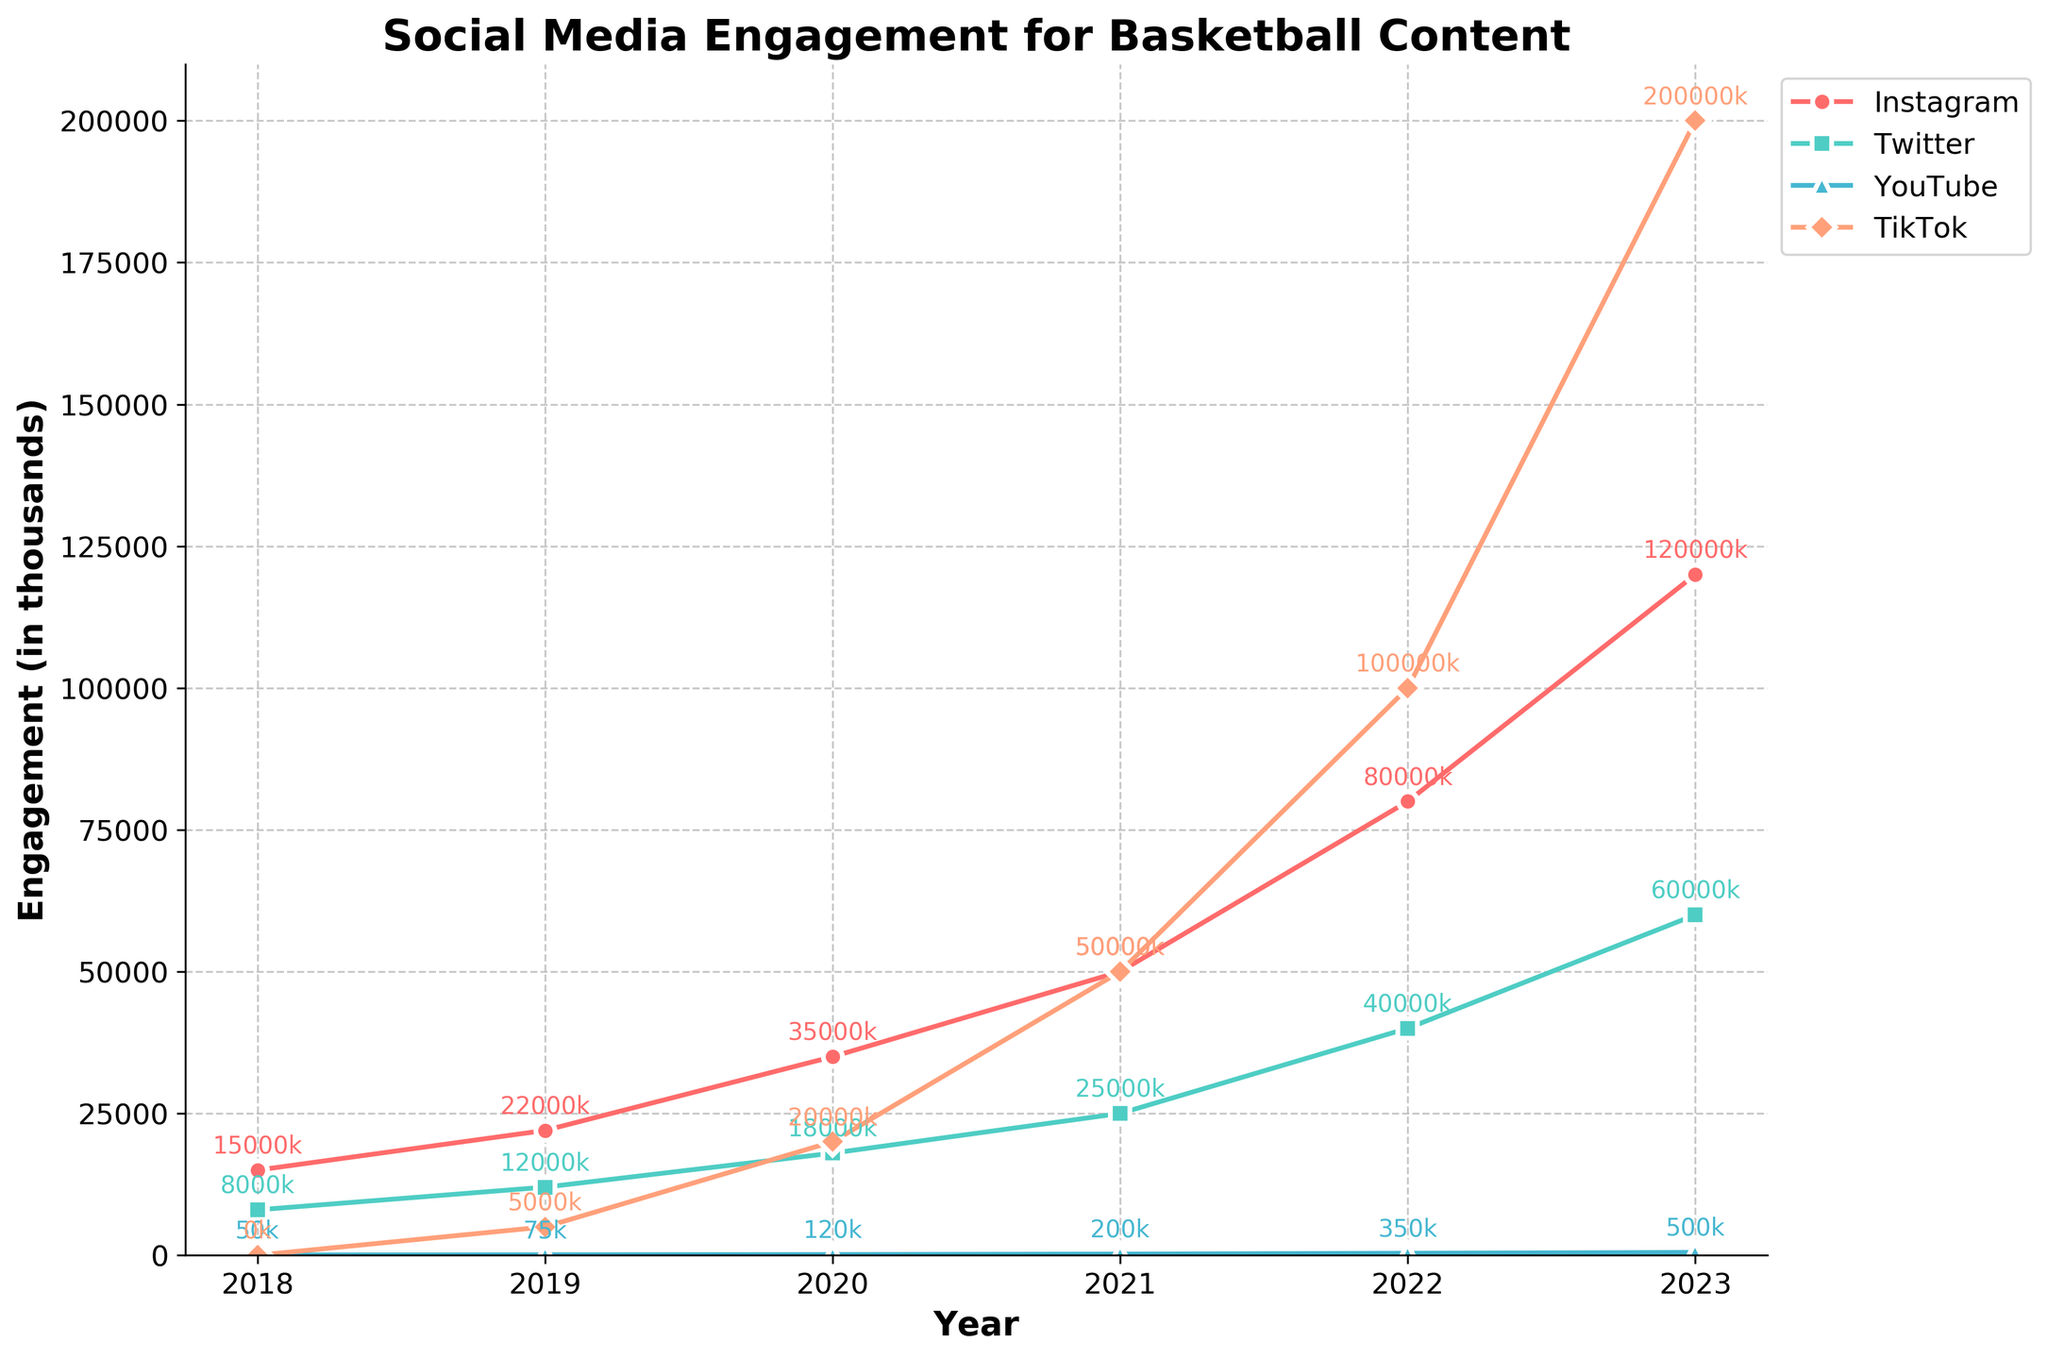Which social media platform had the highest engagement in 2023? By looking at the highest data point in 2023, we notice the figure shows the highest number of engagements on YouTube, with 500,000 views (which is 500k in thousands).
Answer: YouTube How much did Instagram likes increase from 2018 to 2023? In 2018, Instagram likes were 15,000, and in 2023, they were 120,000. The increase is calculated as 120,000 - 15,000 = 105,000.
Answer: 105,000 Which platform saw the most significant increase in likes/engagements from 2018 to 2023? Measure the difference for each platform from 2018 to 2023. The differences are: Instagram (120,000 - 15,000 = 105,000), Twitter (60,000 - 8,000 = 52,000), YouTube (500,000/1000 - 50 = 450 thousand), and TikTok (200,000 - 0 = 200,000). TikTok has the largest increase (200,000).
Answer: TikTok Between 2020 and 2021, which platform saw the highest relative growth (percentage increase) in engagement? For each platform, calculate the percentage increase from 2020 to 2021:
- Instagram: ((50,000 - 35,000) / 35,000) * 100 = 42.86%
- Twitter: ((25,000 - 18,000) / 18,000) * 100 = 38.89%
- YouTube: ((200,000 - 120,000) / 120,000) * 100 = 66.67%
- TikTok: ((50,000 - 20,000) / 20,000) * 100 = 150%
TikTok shows the highest percentage increase.
Answer: TikTok In what year did Twitter likes surpass Instagram comments? Compare Twitter likes and Instagram comments for each year and find the point where Twitter likes exceed Instagram comments. This occurs starting in 2020: Twitter (18,000) vs Instagram (2,000).
Answer: 2020 What is the average engagement (in thousands) on YouTube over the years? Convert YouTube views into thousands (50, 75, 120, 200, 350, and 500). Sum these values and divide by the number of years: (50 + 75 + 120 + 200 + 350 + 500) / 6 = 1291 / 6 = 215.17k.
Answer: 215.17k Which platform had the smallest increase in engagements from 2019 to 2020? Calculate the increase for each platform:
- Instagram: 35,000 - 22,000 = 13,000
- Twitter: 18,000 - 12,000 = 6,000
- YouTube: 120,000 - 75,000 = 45,000 (or 45k in thousands)
- TikTok: 20,000 - 5,000 = 15,000
Twitter shows the smallest increase of 6,000.
Answer: Twitter In 2022, which social media platform had the highest rate of increase compared to the previous year (2021)? Calculate the rate of increase:
- Instagram: ((80,000 - 50,000) / 50,000) * 100 = 60%
- Twitter: ((40,000 - 25,000) / 25,000) * 100 = 60%
- YouTube: ((350,000 - 200,000) / 200,000) * 100 = 75%
- TikTok: ((100,000 - 50,000) / 50,000) * 100 = 100%
TikTok has the highest rate of increase with 100%.
Answer: TikTok 